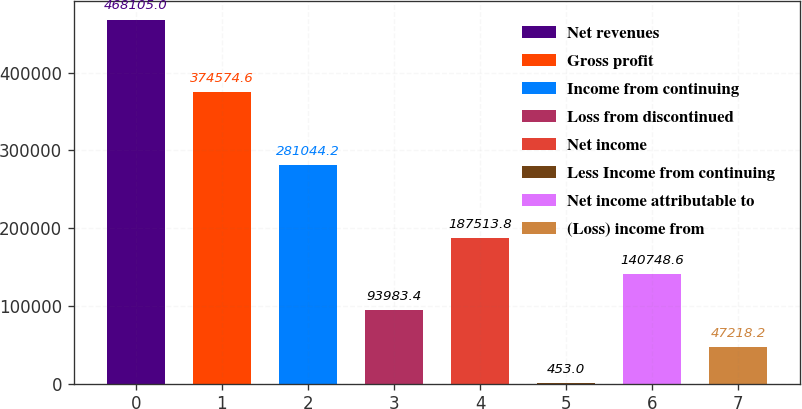Convert chart. <chart><loc_0><loc_0><loc_500><loc_500><bar_chart><fcel>Net revenues<fcel>Gross profit<fcel>Income from continuing<fcel>Loss from discontinued<fcel>Net income<fcel>Less Income from continuing<fcel>Net income attributable to<fcel>(Loss) income from<nl><fcel>468105<fcel>374575<fcel>281044<fcel>93983.4<fcel>187514<fcel>453<fcel>140749<fcel>47218.2<nl></chart> 